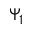Convert formula to latex. <formula><loc_0><loc_0><loc_500><loc_500>\Psi _ { 1 }</formula> 